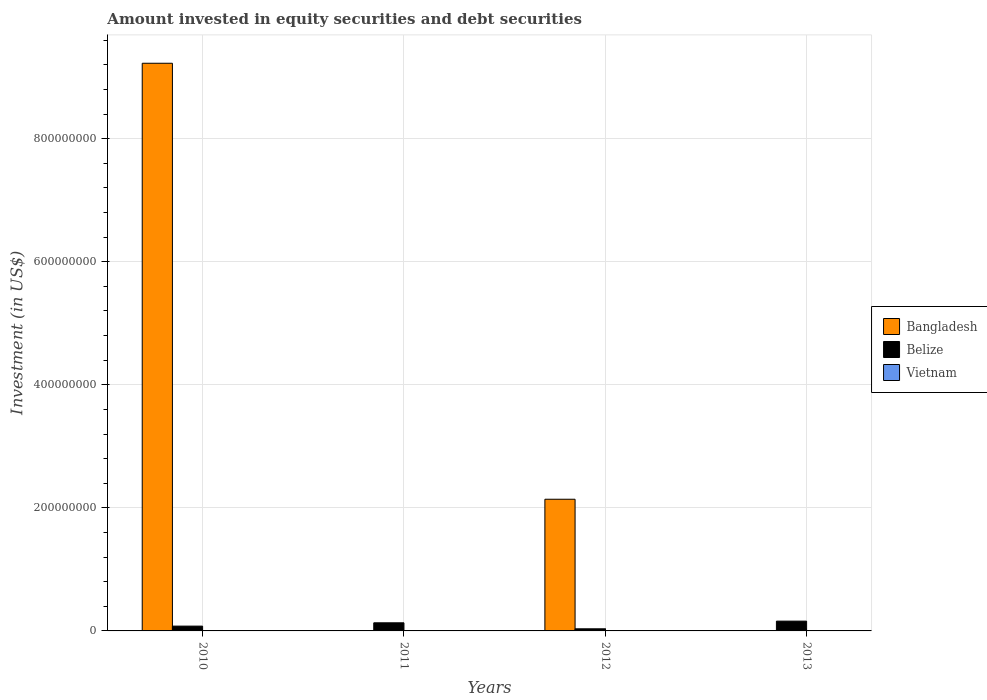How many different coloured bars are there?
Your answer should be very brief. 2. Are the number of bars per tick equal to the number of legend labels?
Make the answer very short. No. How many bars are there on the 4th tick from the right?
Keep it short and to the point. 2. What is the amount invested in equity securities and debt securities in Vietnam in 2013?
Your answer should be very brief. 0. Across all years, what is the maximum amount invested in equity securities and debt securities in Belize?
Give a very brief answer. 1.59e+07. Across all years, what is the minimum amount invested in equity securities and debt securities in Belize?
Make the answer very short. 3.43e+06. In which year was the amount invested in equity securities and debt securities in Belize maximum?
Offer a very short reply. 2013. What is the total amount invested in equity securities and debt securities in Bangladesh in the graph?
Provide a short and direct response. 1.14e+09. What is the difference between the amount invested in equity securities and debt securities in Bangladesh in 2010 and that in 2012?
Offer a terse response. 7.09e+08. What is the difference between the amount invested in equity securities and debt securities in Vietnam in 2010 and the amount invested in equity securities and debt securities in Belize in 2012?
Offer a very short reply. -3.43e+06. What is the average amount invested in equity securities and debt securities in Belize per year?
Keep it short and to the point. 1.01e+07. In the year 2012, what is the difference between the amount invested in equity securities and debt securities in Belize and amount invested in equity securities and debt securities in Bangladesh?
Offer a very short reply. -2.11e+08. In how many years, is the amount invested in equity securities and debt securities in Bangladesh greater than 640000000 US$?
Your answer should be very brief. 1. What is the ratio of the amount invested in equity securities and debt securities in Belize in 2010 to that in 2012?
Your answer should be compact. 2.28. What is the difference between the highest and the second highest amount invested in equity securities and debt securities in Belize?
Offer a terse response. 2.72e+06. What is the difference between the highest and the lowest amount invested in equity securities and debt securities in Bangladesh?
Provide a succinct answer. 9.23e+08. Is it the case that in every year, the sum of the amount invested in equity securities and debt securities in Belize and amount invested in equity securities and debt securities in Vietnam is greater than the amount invested in equity securities and debt securities in Bangladesh?
Provide a short and direct response. No. How many bars are there?
Your answer should be compact. 6. How many years are there in the graph?
Offer a very short reply. 4. Are the values on the major ticks of Y-axis written in scientific E-notation?
Keep it short and to the point. No. What is the title of the graph?
Offer a terse response. Amount invested in equity securities and debt securities. What is the label or title of the Y-axis?
Provide a succinct answer. Investment (in US$). What is the Investment (in US$) of Bangladesh in 2010?
Your answer should be compact. 9.23e+08. What is the Investment (in US$) in Belize in 2010?
Give a very brief answer. 7.81e+06. What is the Investment (in US$) of Belize in 2011?
Your answer should be compact. 1.32e+07. What is the Investment (in US$) of Vietnam in 2011?
Your answer should be very brief. 0. What is the Investment (in US$) of Bangladesh in 2012?
Provide a short and direct response. 2.14e+08. What is the Investment (in US$) in Belize in 2012?
Provide a short and direct response. 3.43e+06. What is the Investment (in US$) in Belize in 2013?
Give a very brief answer. 1.59e+07. Across all years, what is the maximum Investment (in US$) of Bangladesh?
Your answer should be very brief. 9.23e+08. Across all years, what is the maximum Investment (in US$) of Belize?
Your response must be concise. 1.59e+07. Across all years, what is the minimum Investment (in US$) in Belize?
Your response must be concise. 3.43e+06. What is the total Investment (in US$) in Bangladesh in the graph?
Ensure brevity in your answer.  1.14e+09. What is the total Investment (in US$) in Belize in the graph?
Your answer should be very brief. 4.04e+07. What is the total Investment (in US$) in Vietnam in the graph?
Keep it short and to the point. 0. What is the difference between the Investment (in US$) of Belize in 2010 and that in 2011?
Make the answer very short. -5.38e+06. What is the difference between the Investment (in US$) of Bangladesh in 2010 and that in 2012?
Your answer should be very brief. 7.09e+08. What is the difference between the Investment (in US$) of Belize in 2010 and that in 2012?
Provide a short and direct response. 4.39e+06. What is the difference between the Investment (in US$) of Belize in 2010 and that in 2013?
Ensure brevity in your answer.  -8.10e+06. What is the difference between the Investment (in US$) of Belize in 2011 and that in 2012?
Make the answer very short. 9.77e+06. What is the difference between the Investment (in US$) in Belize in 2011 and that in 2013?
Keep it short and to the point. -2.72e+06. What is the difference between the Investment (in US$) in Belize in 2012 and that in 2013?
Provide a succinct answer. -1.25e+07. What is the difference between the Investment (in US$) in Bangladesh in 2010 and the Investment (in US$) in Belize in 2011?
Your answer should be compact. 9.09e+08. What is the difference between the Investment (in US$) in Bangladesh in 2010 and the Investment (in US$) in Belize in 2012?
Give a very brief answer. 9.19e+08. What is the difference between the Investment (in US$) in Bangladesh in 2010 and the Investment (in US$) in Belize in 2013?
Your answer should be very brief. 9.07e+08. What is the difference between the Investment (in US$) of Bangladesh in 2012 and the Investment (in US$) of Belize in 2013?
Offer a very short reply. 1.98e+08. What is the average Investment (in US$) in Bangladesh per year?
Offer a terse response. 2.84e+08. What is the average Investment (in US$) of Belize per year?
Offer a very short reply. 1.01e+07. In the year 2010, what is the difference between the Investment (in US$) in Bangladesh and Investment (in US$) in Belize?
Your response must be concise. 9.15e+08. In the year 2012, what is the difference between the Investment (in US$) of Bangladesh and Investment (in US$) of Belize?
Provide a short and direct response. 2.11e+08. What is the ratio of the Investment (in US$) of Belize in 2010 to that in 2011?
Keep it short and to the point. 0.59. What is the ratio of the Investment (in US$) of Bangladesh in 2010 to that in 2012?
Ensure brevity in your answer.  4.31. What is the ratio of the Investment (in US$) of Belize in 2010 to that in 2012?
Ensure brevity in your answer.  2.28. What is the ratio of the Investment (in US$) of Belize in 2010 to that in 2013?
Provide a short and direct response. 0.49. What is the ratio of the Investment (in US$) in Belize in 2011 to that in 2012?
Give a very brief answer. 3.85. What is the ratio of the Investment (in US$) of Belize in 2011 to that in 2013?
Your answer should be compact. 0.83. What is the ratio of the Investment (in US$) of Belize in 2012 to that in 2013?
Make the answer very short. 0.22. What is the difference between the highest and the second highest Investment (in US$) in Belize?
Give a very brief answer. 2.72e+06. What is the difference between the highest and the lowest Investment (in US$) in Bangladesh?
Keep it short and to the point. 9.23e+08. What is the difference between the highest and the lowest Investment (in US$) of Belize?
Give a very brief answer. 1.25e+07. 